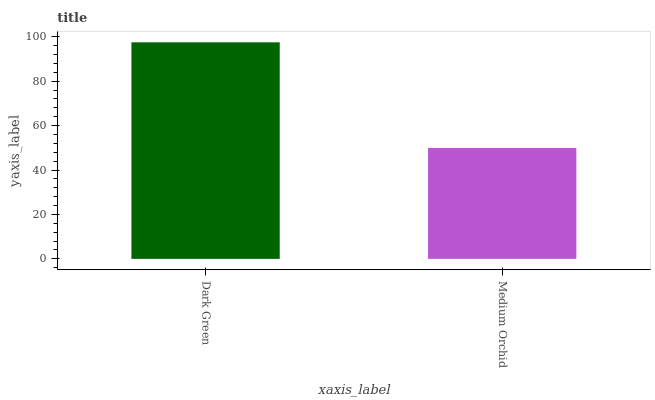Is Medium Orchid the minimum?
Answer yes or no. Yes. Is Dark Green the maximum?
Answer yes or no. Yes. Is Medium Orchid the maximum?
Answer yes or no. No. Is Dark Green greater than Medium Orchid?
Answer yes or no. Yes. Is Medium Orchid less than Dark Green?
Answer yes or no. Yes. Is Medium Orchid greater than Dark Green?
Answer yes or no. No. Is Dark Green less than Medium Orchid?
Answer yes or no. No. Is Dark Green the high median?
Answer yes or no. Yes. Is Medium Orchid the low median?
Answer yes or no. Yes. Is Medium Orchid the high median?
Answer yes or no. No. Is Dark Green the low median?
Answer yes or no. No. 